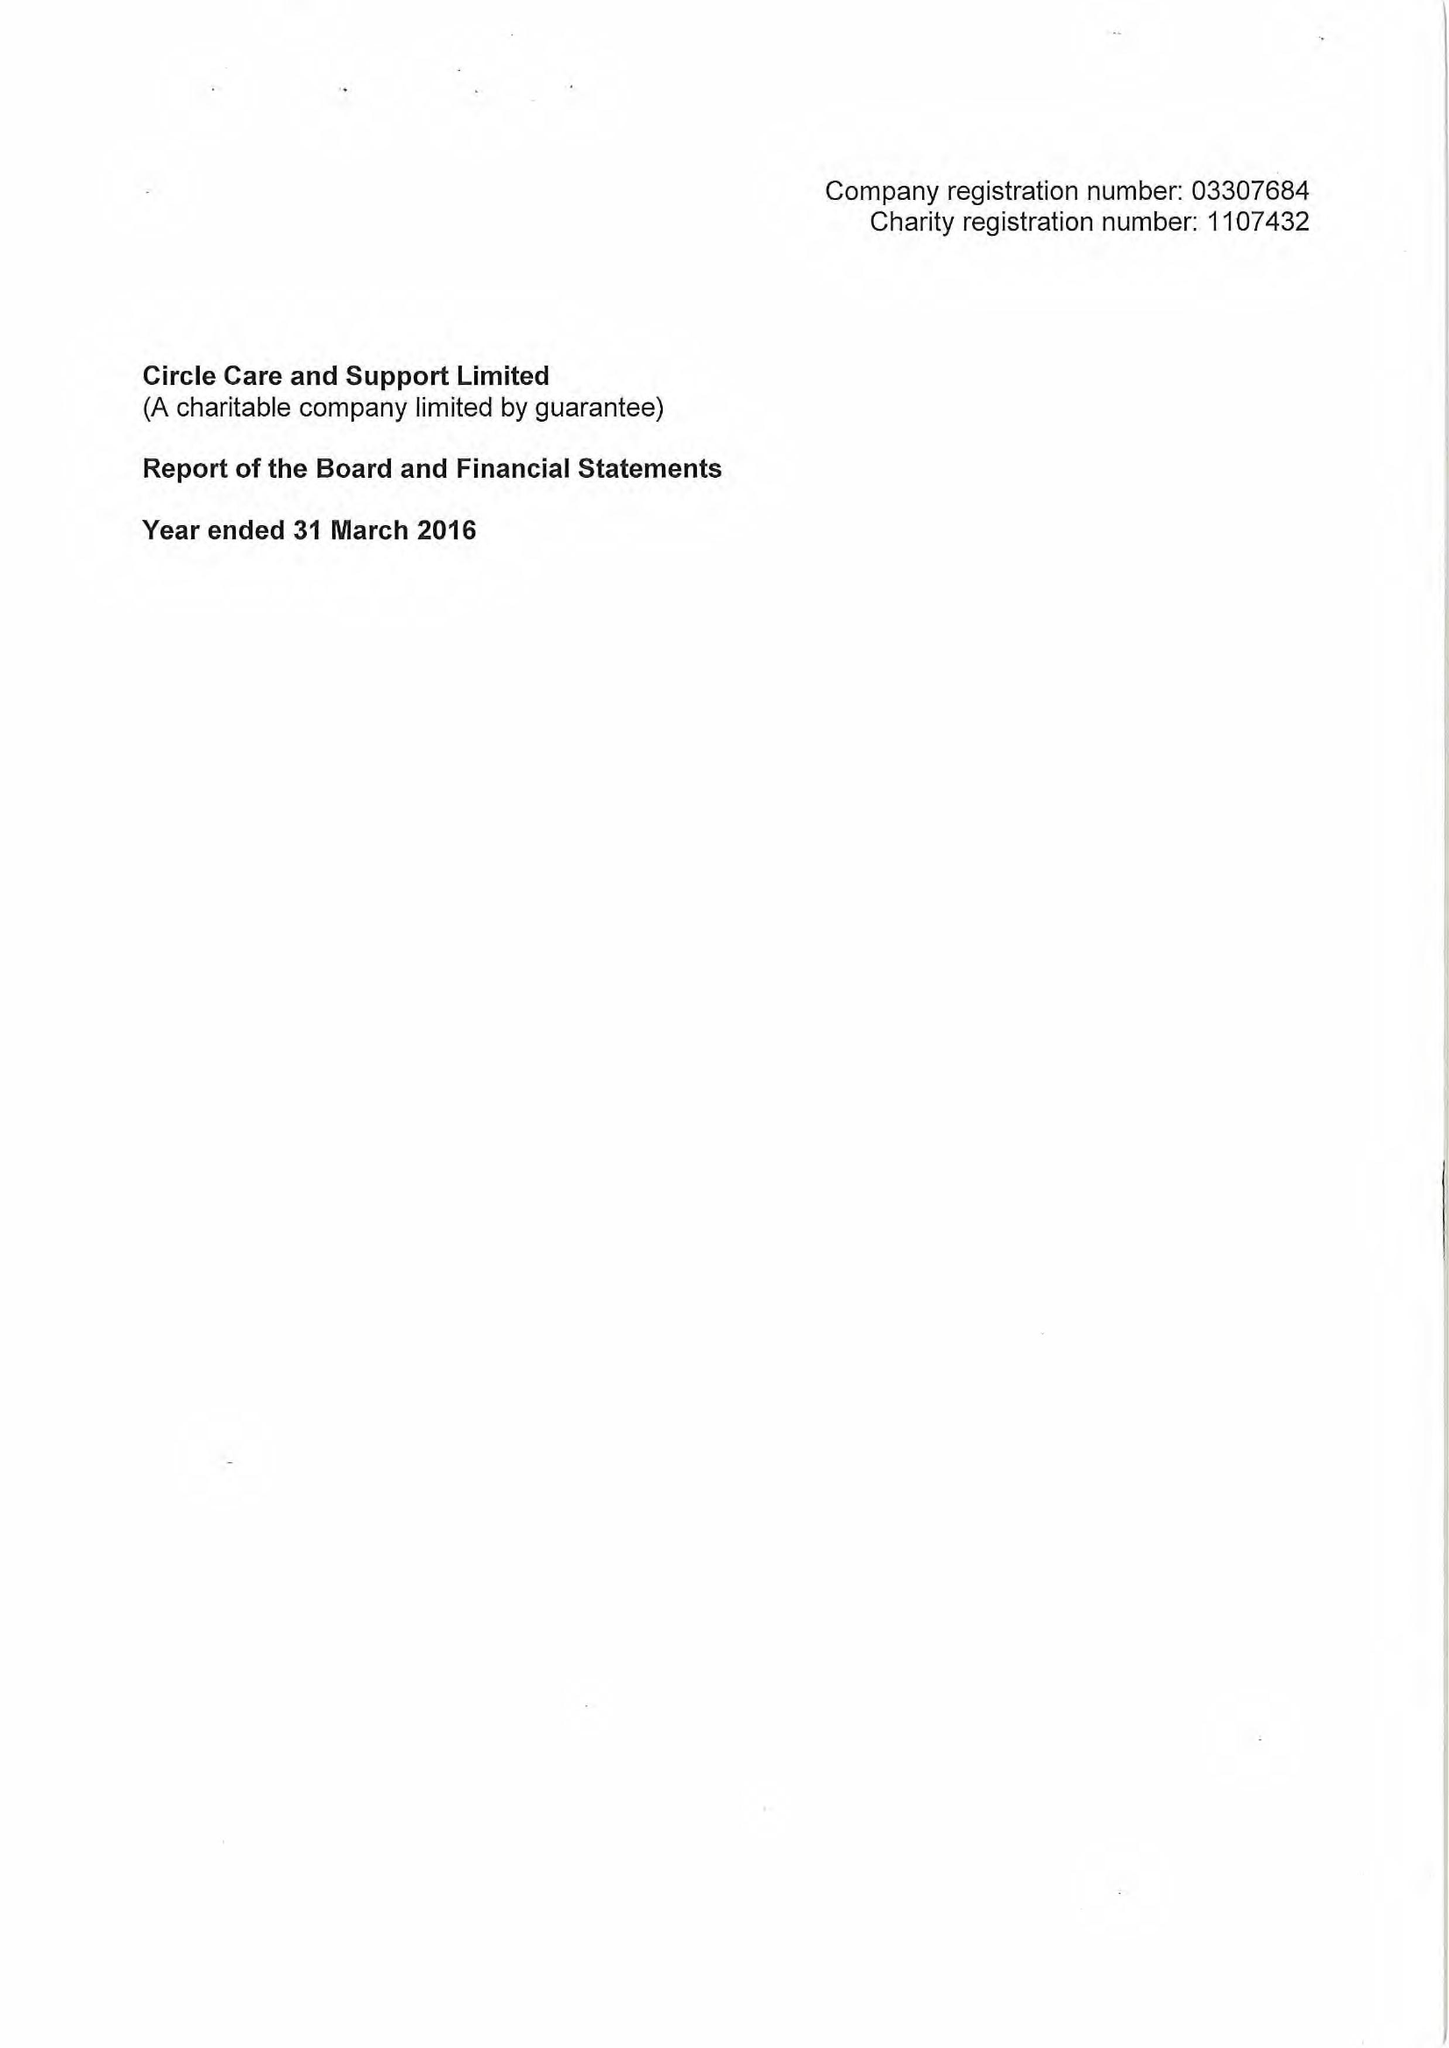What is the value for the spending_annually_in_british_pounds?
Answer the question using a single word or phrase. 16116000.00 